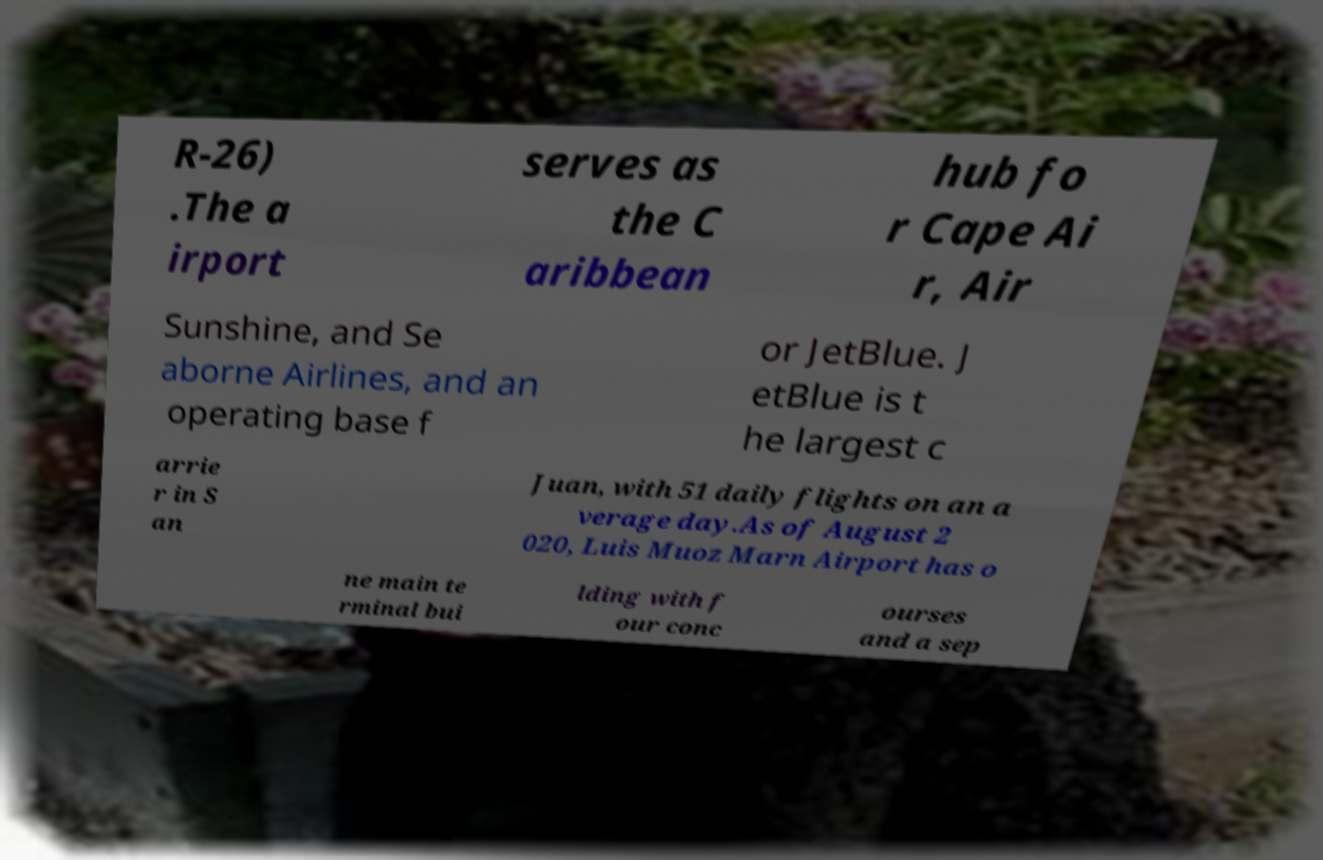Can you read and provide the text displayed in the image?This photo seems to have some interesting text. Can you extract and type it out for me? R-26) .The a irport serves as the C aribbean hub fo r Cape Ai r, Air Sunshine, and Se aborne Airlines, and an operating base f or JetBlue. J etBlue is t he largest c arrie r in S an Juan, with 51 daily flights on an a verage day.As of August 2 020, Luis Muoz Marn Airport has o ne main te rminal bui lding with f our conc ourses and a sep 